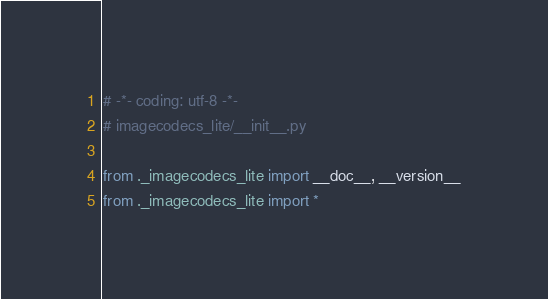Convert code to text. <code><loc_0><loc_0><loc_500><loc_500><_Python_># -*- coding: utf-8 -*-
# imagecodecs_lite/__init__.py

from ._imagecodecs_lite import __doc__, __version__
from ._imagecodecs_lite import *
</code> 